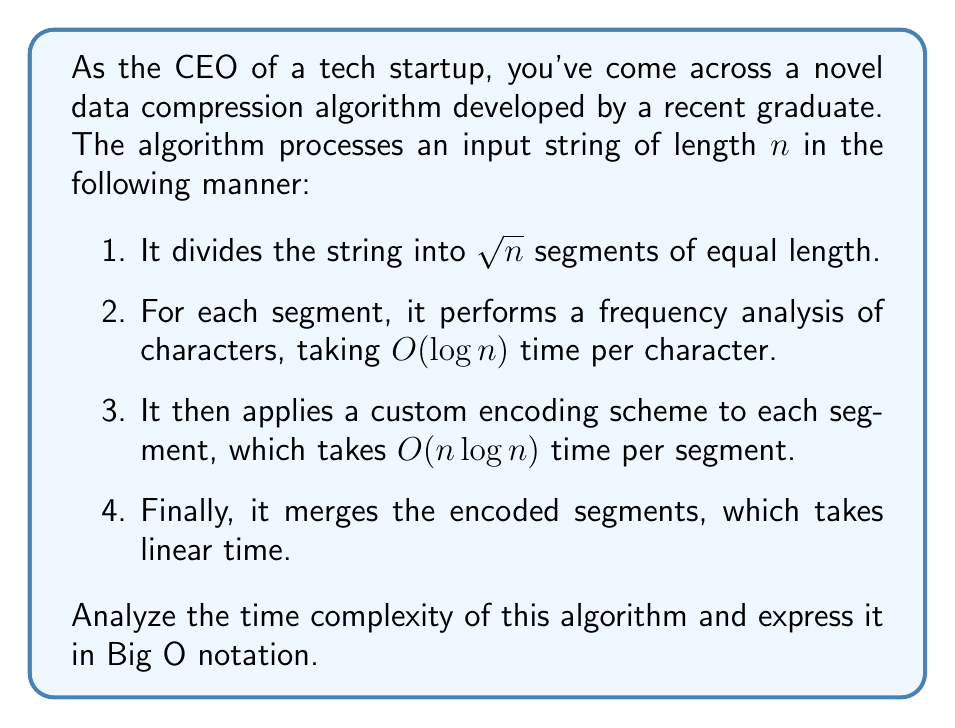Can you solve this math problem? Let's break down the algorithm and analyze each step:

1. Dividing the string into $\sqrt{n}$ segments:
   This step takes $O(n)$ time as it involves a single pass through the string.

2. Frequency analysis for each segment:
   - There are $\sqrt{n}$ segments
   - Each segment has $\frac{n}{\sqrt{n}} = \sqrt{n}$ characters
   - For each character, the analysis takes $O(\log n)$ time
   - Total time for this step: $O(\sqrt{n} \cdot \sqrt{n} \cdot \log n) = O(n \log n)$

3. Custom encoding for each segment:
   - There are $\sqrt{n}$ segments
   - Each segment takes $O(n \log n)$ time to encode
   - Total time for this step: $O(\sqrt{n} \cdot n \log n) = O(n^{1.5} \log n)$

4. Merging the encoded segments:
   This step takes $O(n)$ time as it's linear in the input size.

Now, we need to sum up the time complexities of all steps:

$$ T(n) = O(n) + O(n \log n) + O(n^{1.5} \log n) + O(n) $$

The dominant term in this sum is $O(n^{1.5} \log n)$, as it grows faster than the others for large $n$.

Therefore, the overall time complexity of the algorithm is $O(n^{1.5} \log n)$.
Answer: $O(n^{1.5} \log n)$ 